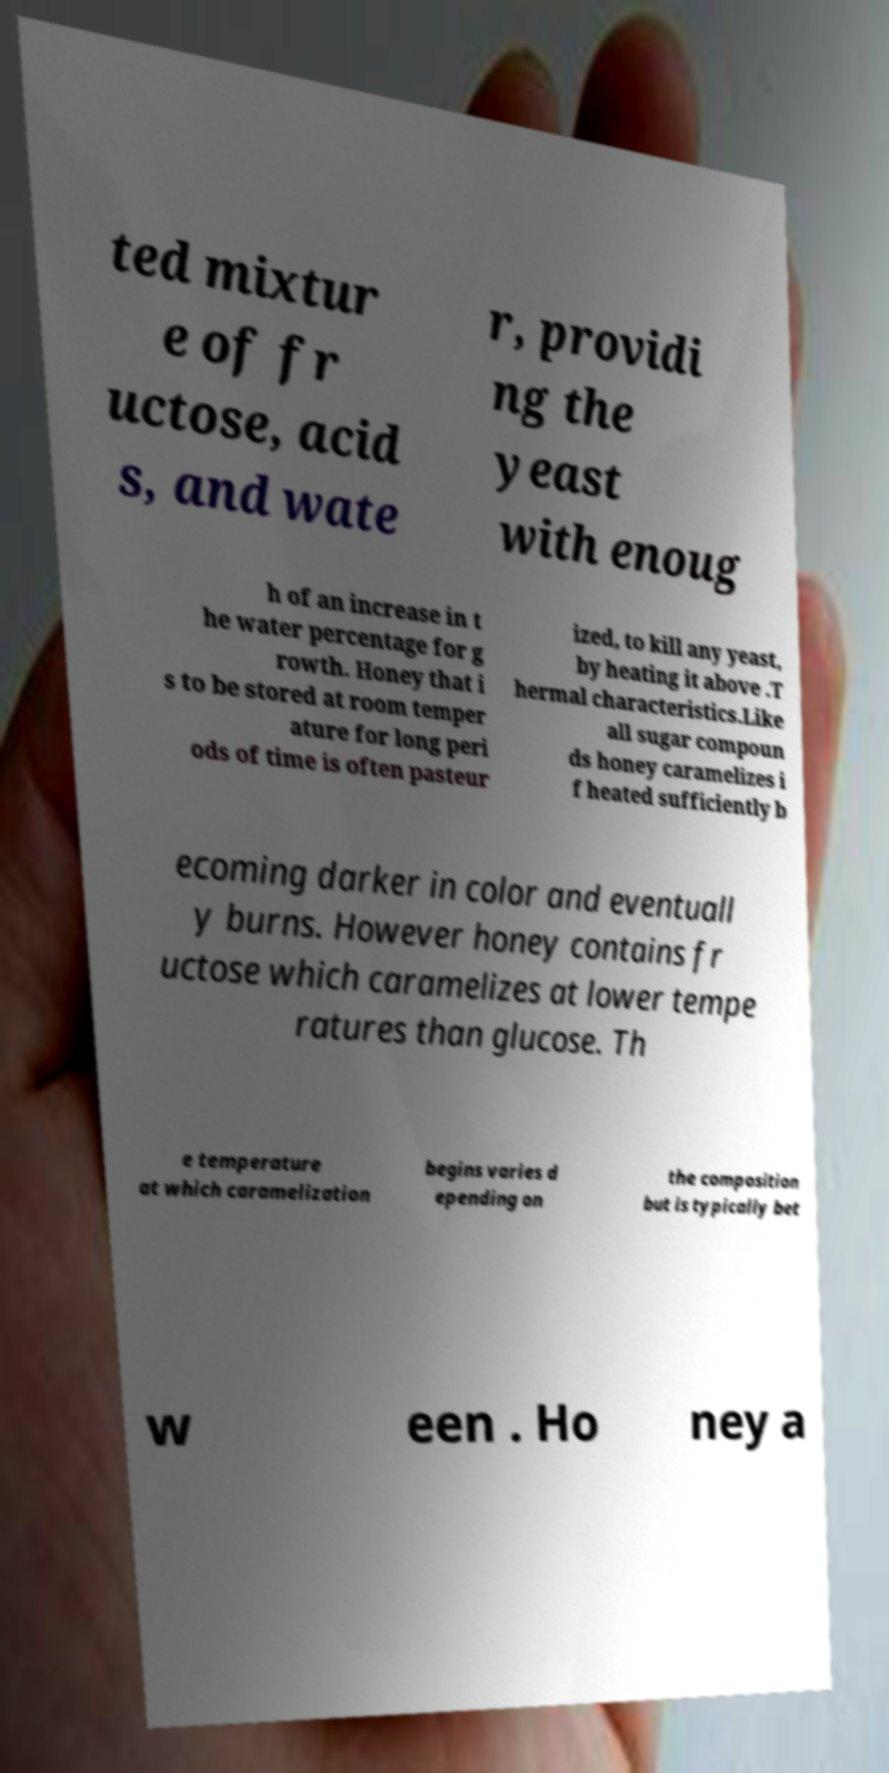There's text embedded in this image that I need extracted. Can you transcribe it verbatim? ted mixtur e of fr uctose, acid s, and wate r, providi ng the yeast with enoug h of an increase in t he water percentage for g rowth. Honey that i s to be stored at room temper ature for long peri ods of time is often pasteur ized, to kill any yeast, by heating it above .T hermal characteristics.Like all sugar compoun ds honey caramelizes i f heated sufficiently b ecoming darker in color and eventuall y burns. However honey contains fr uctose which caramelizes at lower tempe ratures than glucose. Th e temperature at which caramelization begins varies d epending on the composition but is typically bet w een . Ho ney a 